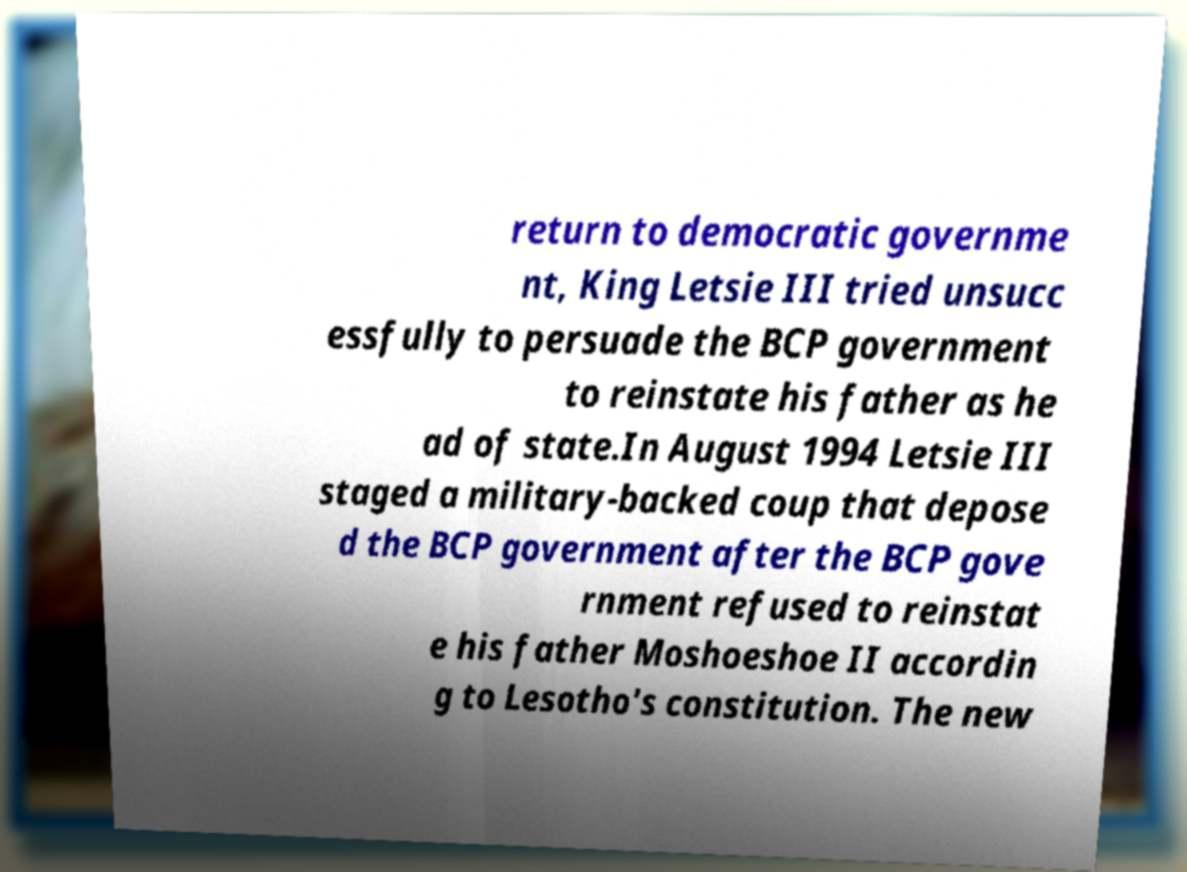For documentation purposes, I need the text within this image transcribed. Could you provide that? return to democratic governme nt, King Letsie III tried unsucc essfully to persuade the BCP government to reinstate his father as he ad of state.In August 1994 Letsie III staged a military-backed coup that depose d the BCP government after the BCP gove rnment refused to reinstat e his father Moshoeshoe II accordin g to Lesotho's constitution. The new 